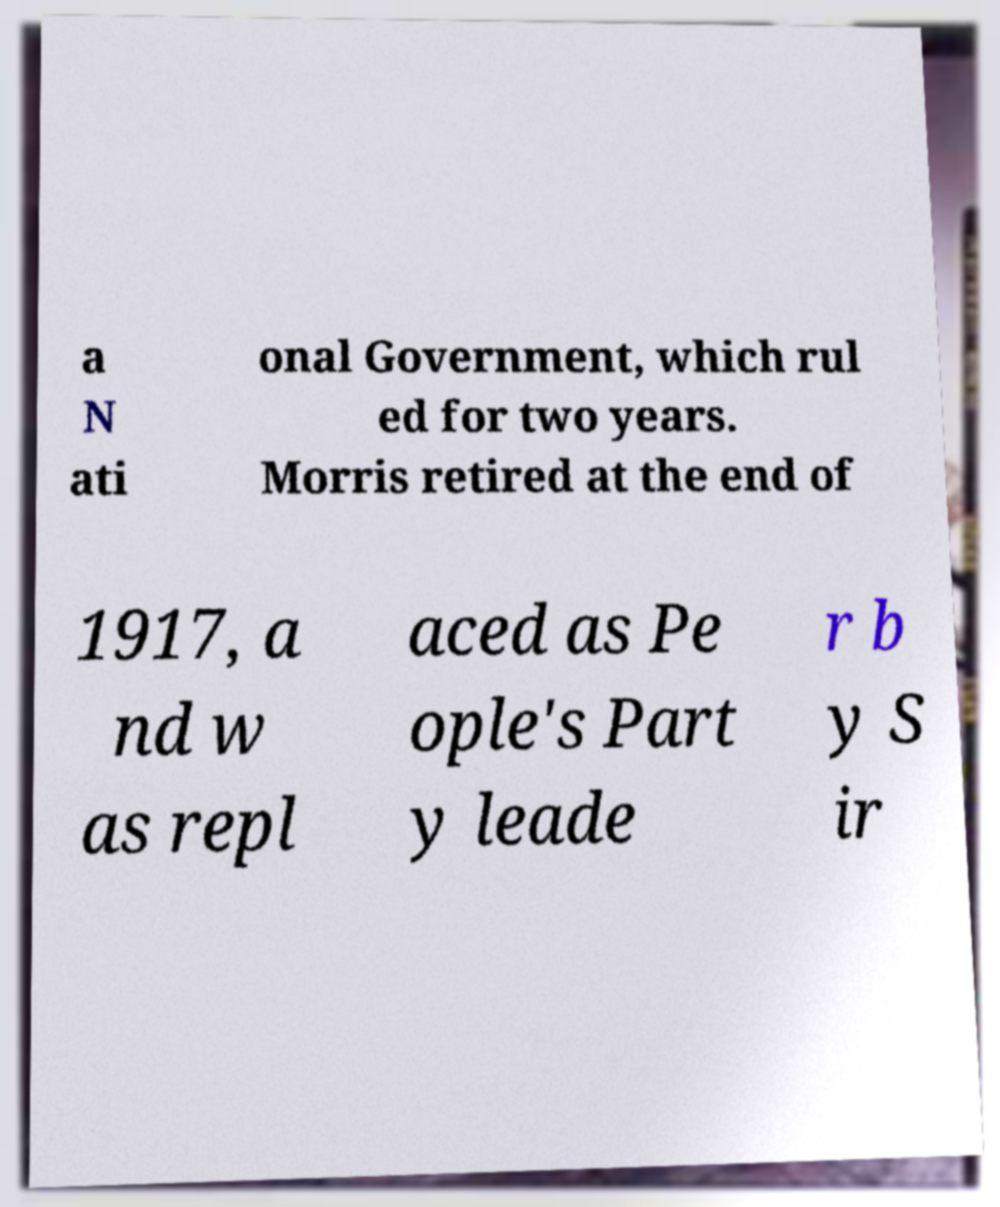Please identify and transcribe the text found in this image. a N ati onal Government, which rul ed for two years. Morris retired at the end of 1917, a nd w as repl aced as Pe ople's Part y leade r b y S ir 